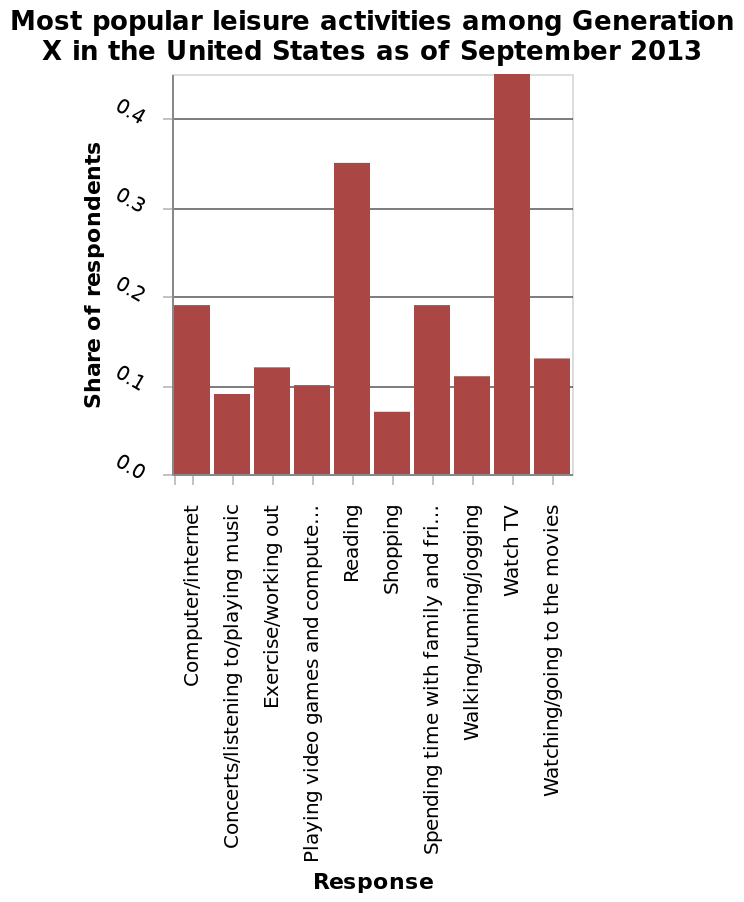<image>
please enumerates aspects of the construction of the chart Most popular leisure activities among Generation X in the United States as of September 2013 is a bar chart. The x-axis shows Response on categorical scale starting at Computer/internet and ending at  while the y-axis measures Share of respondents with linear scale with a minimum of 0.0 and a maximum of 0.4. Which activity closely follows watching TV as the favourite leisure activity of generation X?  Reading Offer a thorough analysis of the image. The favourite leisure activity of generation X is watching TV, closely followed by reading. These 2 activities are the only ones that go above 0.2 on the Y axis. 